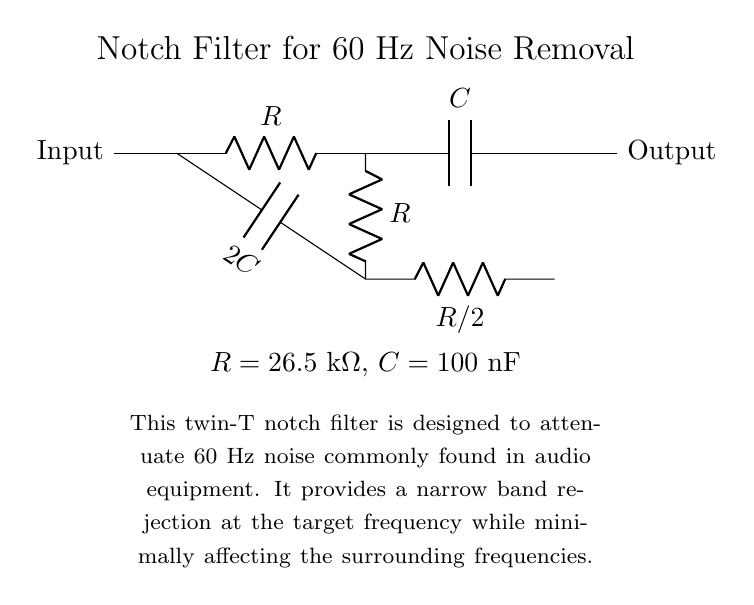What does the label "Input" signify in the circuit? The label "Input" identifies the point where the audio signal enters the notch filter circuit. This is critical as it indicates where the noise will be processed and attenuated.
Answer: Input What kind of filter is depicted in this circuit? The circuit illustrates a twin-T notch filter, specifically designed to reduce specific frequency noise while allowing others to pass. This type of filter is effective for noise cancellation tasks.
Answer: Notch filter What is the resistance value of R in the circuit? The circuit specifies that the resistance R has a value of 26.5 kilo-ohms, which can be seen in the diagram alongside the resistor labels.
Answer: 26.5 kΩ How many capacitors are present in the circuit? The circuit diagram shows two capacitors - one capacitor with the value of C and another with a value of 2C, located at different parts of the circuit.
Answer: 2 Why is the notch filter particularly useful for audio equipment? The notch filter is effective in removing unwanted noise at a specific frequency, in this case, 60 Hz, which is common in audio signals from electrical interference. This helps maintain audio quality by ensuring that the desired signals are not masked by noise.
Answer: To remove 60 Hz noise What happens to the signal at 60 Hz when it passes through this circuit? The circuit is designed to significantly attenuate signals at the 60 Hz frequency while allowing other frequencies to pass with minimal loss, effectively reducing interference from this specific noise.
Answer: Attenuated What are the capacitance values used in the filter? The capacitance values are stated in the circuit diagram, with one capacitor having a value of 100 nano-farads and the other being double that at 200 nano-farads.
Answer: 100 nF and 200 nF 